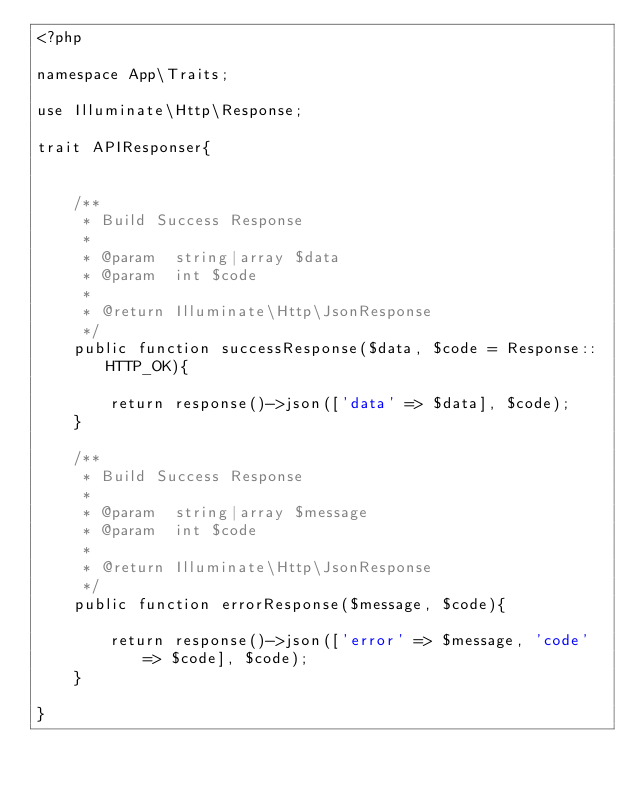Convert code to text. <code><loc_0><loc_0><loc_500><loc_500><_PHP_><?php

namespace App\Traits;

use Illuminate\Http\Response;

trait APIResponser{


    /**
     * Build Success Response
     *
     * @param  string|array $data
     * @param  int $code
     *
     * @return Illuminate\Http\JsonResponse
     */
    public function successResponse($data, $code = Response::HTTP_OK){

        return response()->json(['data' => $data], $code);
    }

    /**
     * Build Success Response
     *
     * @param  string|array $message
     * @param  int $code
     *
     * @return Illuminate\Http\JsonResponse
     */
    public function errorResponse($message, $code){

        return response()->json(['error' => $message, 'code' => $code], $code);
    }

}
</code> 